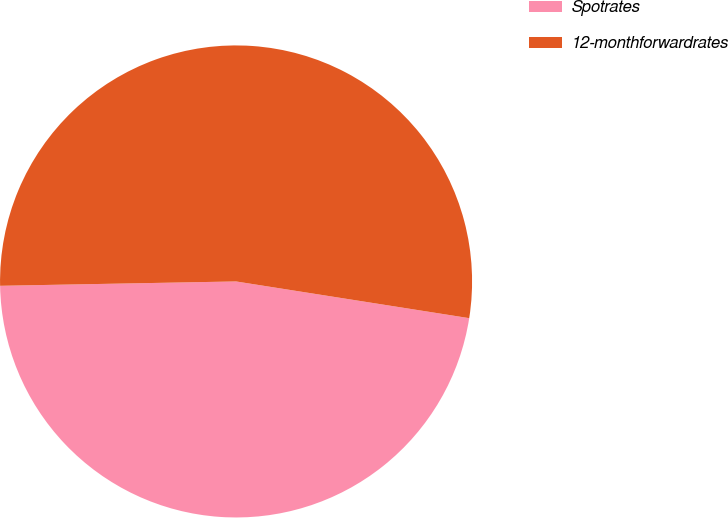<chart> <loc_0><loc_0><loc_500><loc_500><pie_chart><fcel>Spotrates<fcel>12-monthforwardrates<nl><fcel>47.22%<fcel>52.78%<nl></chart> 